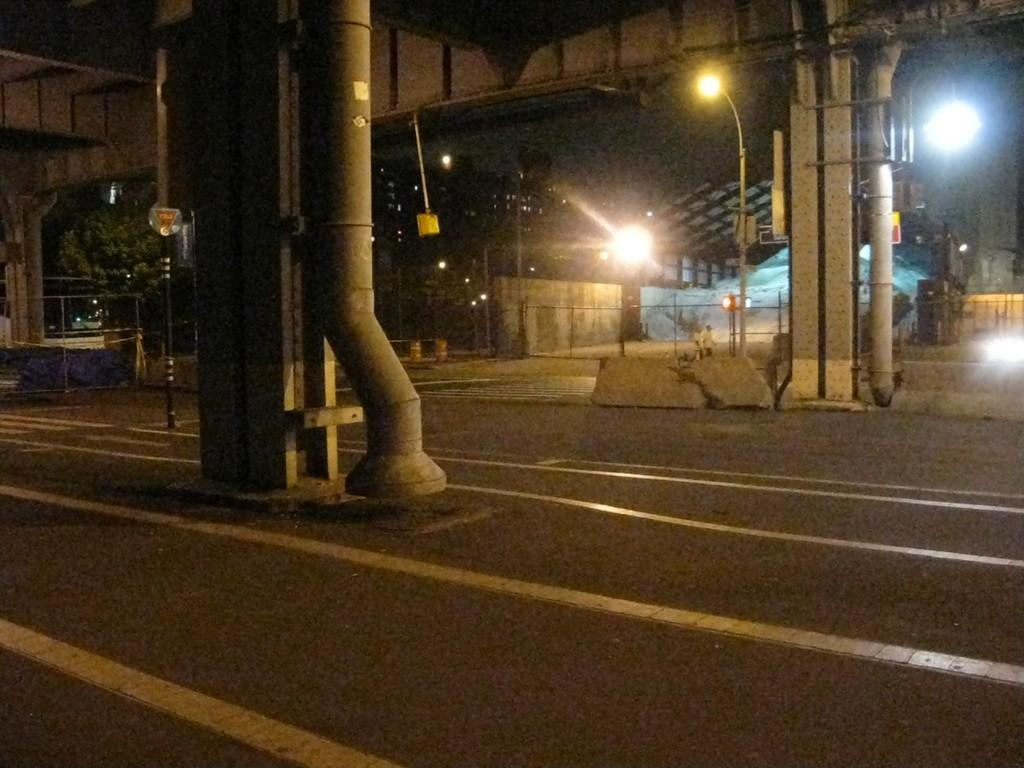What can be seen in the foreground of the image? In the foreground of the image, there is a road, pillars, pipes, poles, lights, a shed, and fencing. What is the primary purpose of the pillars and poles in the image? The pillars and poles in the image are likely used for supporting structures or providing lighting. What can be seen in the background of the image? In the background of the image, there are trees and buildings. Where are the ants carrying the map in the image? There are no ants or maps present in the image. What type of food is served on the plate in the image? There is no plate or food present in the image. 